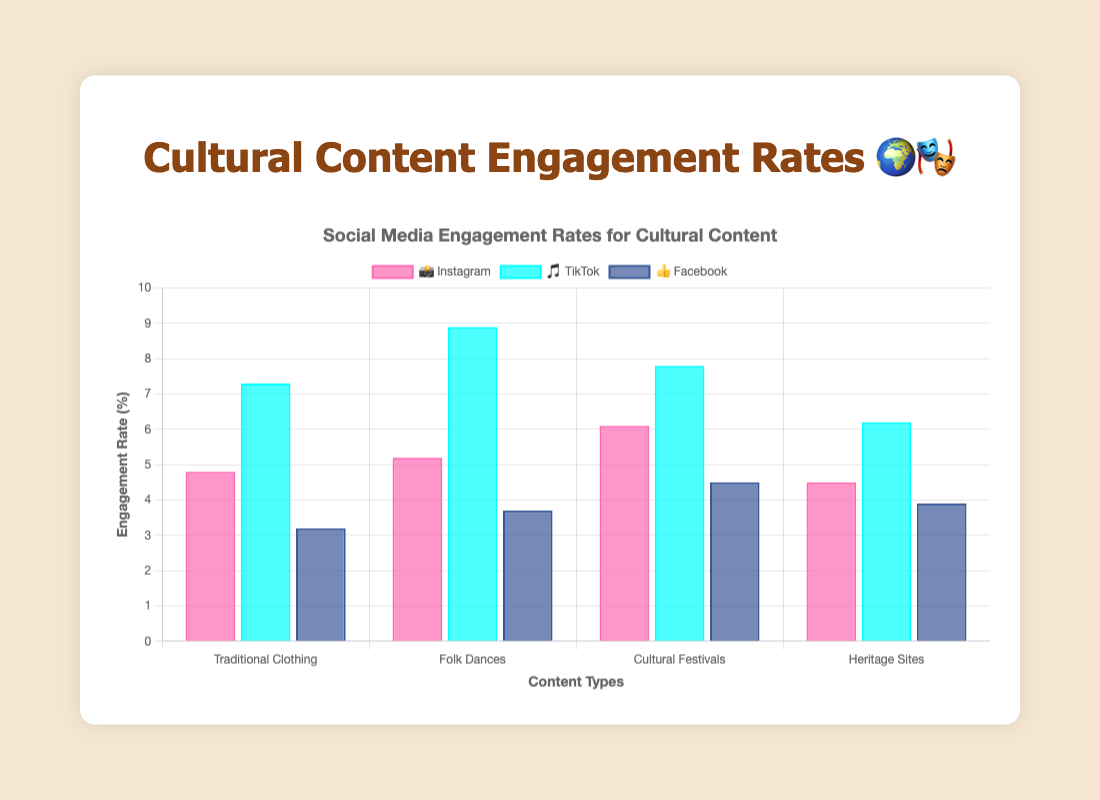What is the highest engagement rate on TikTok 🎵? The highest engagement rate on TikTok 🎵 is among "Folk Dances" with an engagement rate of 8.9%.
Answer: 8.9% Which type of content has the lowest engagement rate on Facebook 👍? On Facebook 👍, "Traditional Clothing" has the lowest engagement rate with 3.2%.
Answer: Traditional Clothing How does the engagement rate of "Cultural Festivals" on Instagram 📸 compare to Facebook 👍? "Cultural Festivals" have an engagement rate of 6.1% on Instagram 📸, whereas on Facebook 👍, it is 4.5%. Hence, it is higher on Instagram 📸.
Answer: Instagram has a higher rate What is the average engagement rate for "Heritage Sites" across all platforms? The engagement rates for "Heritage Sites" are 4.5% on Instagram 📸, 6.2% on TikTok 🎵, and 3.9% on Facebook 👍. The average is calculated as (4.5 + 6.2 + 3.9) / 3 = 4.87%.
Answer: 4.87% Which platform shows the highest overall engagement rates for "Traditional Clothing"? The engagement rates for "Traditional Clothing" are 4.8% on Instagram 📸, 7.3% on TikTok 🎵, and 3.2% on Facebook 👍. The highest rate is on TikTok 🎵.
Answer: TikTok Are there any types of cultural content for which Facebook 👍 has a higher engagement rate than TikTok 🎵? No, after comparing the engagement rates for all types of cultural content, TikTok 🎵 always has higher rates than Facebook 👍.
Answer: No What is the cumulative engagement rate for "Folk Dances" across all platforms? The engagement rates for "Folk Dances" are 5.2% on Instagram 📸, 8.9% on TikTok 🎵, and 3.7% on Facebook 👍. The cumulative rate is 5.2 + 8.9 + 3.7 = 17.8%.
Answer: 17.8% By what percentage is TikTok's 🎵 engagement rate for "Folk Dances" higher than Instagram's 📸? TikTok's 🎵 engagement rate for "Folk Dances" is 8.9% and Instagram's 📸 is 5.2%. The percentage increase is calculated as ((8.9 - 5.2) / 5.2) * 100% = 71.15%.
Answer: 71.15% Which platform has the most consistent engagement rates across different types of cultural content? To determine consistency, we can look at the range (difference between maximum and minimum engagement rates) for each platform. Instagram 📸 ranges from 4.5 to 6.1 (1.6), TikTok 🎵 ranges from 6.2 to 8.9 (2.7), and Facebook 👍 ranges from 3.2 to 4.5 (1.3). Facebook 👍 has the smallest range, hence most consistent.
Answer: Facebook Which cultural content type has the highest engagement rate overall, and on which platform? "Folk Dances" on TikTok 🎵 has the highest engagement rate among all content types and platforms, with 8.9%.
Answer: Folk Dances on TikTok 